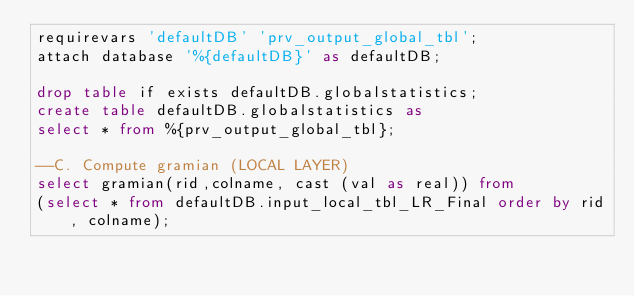Convert code to text. <code><loc_0><loc_0><loc_500><loc_500><_SQL_>requirevars 'defaultDB' 'prv_output_global_tbl';
attach database '%{defaultDB}' as defaultDB;

drop table if exists defaultDB.globalstatistics;
create table defaultDB.globalstatistics as
select * from %{prv_output_global_tbl};

--C. Compute gramian (LOCAL LAYER)
select gramian(rid,colname, cast (val as real)) from
(select * from defaultDB.input_local_tbl_LR_Final order by rid, colname);
</code> 